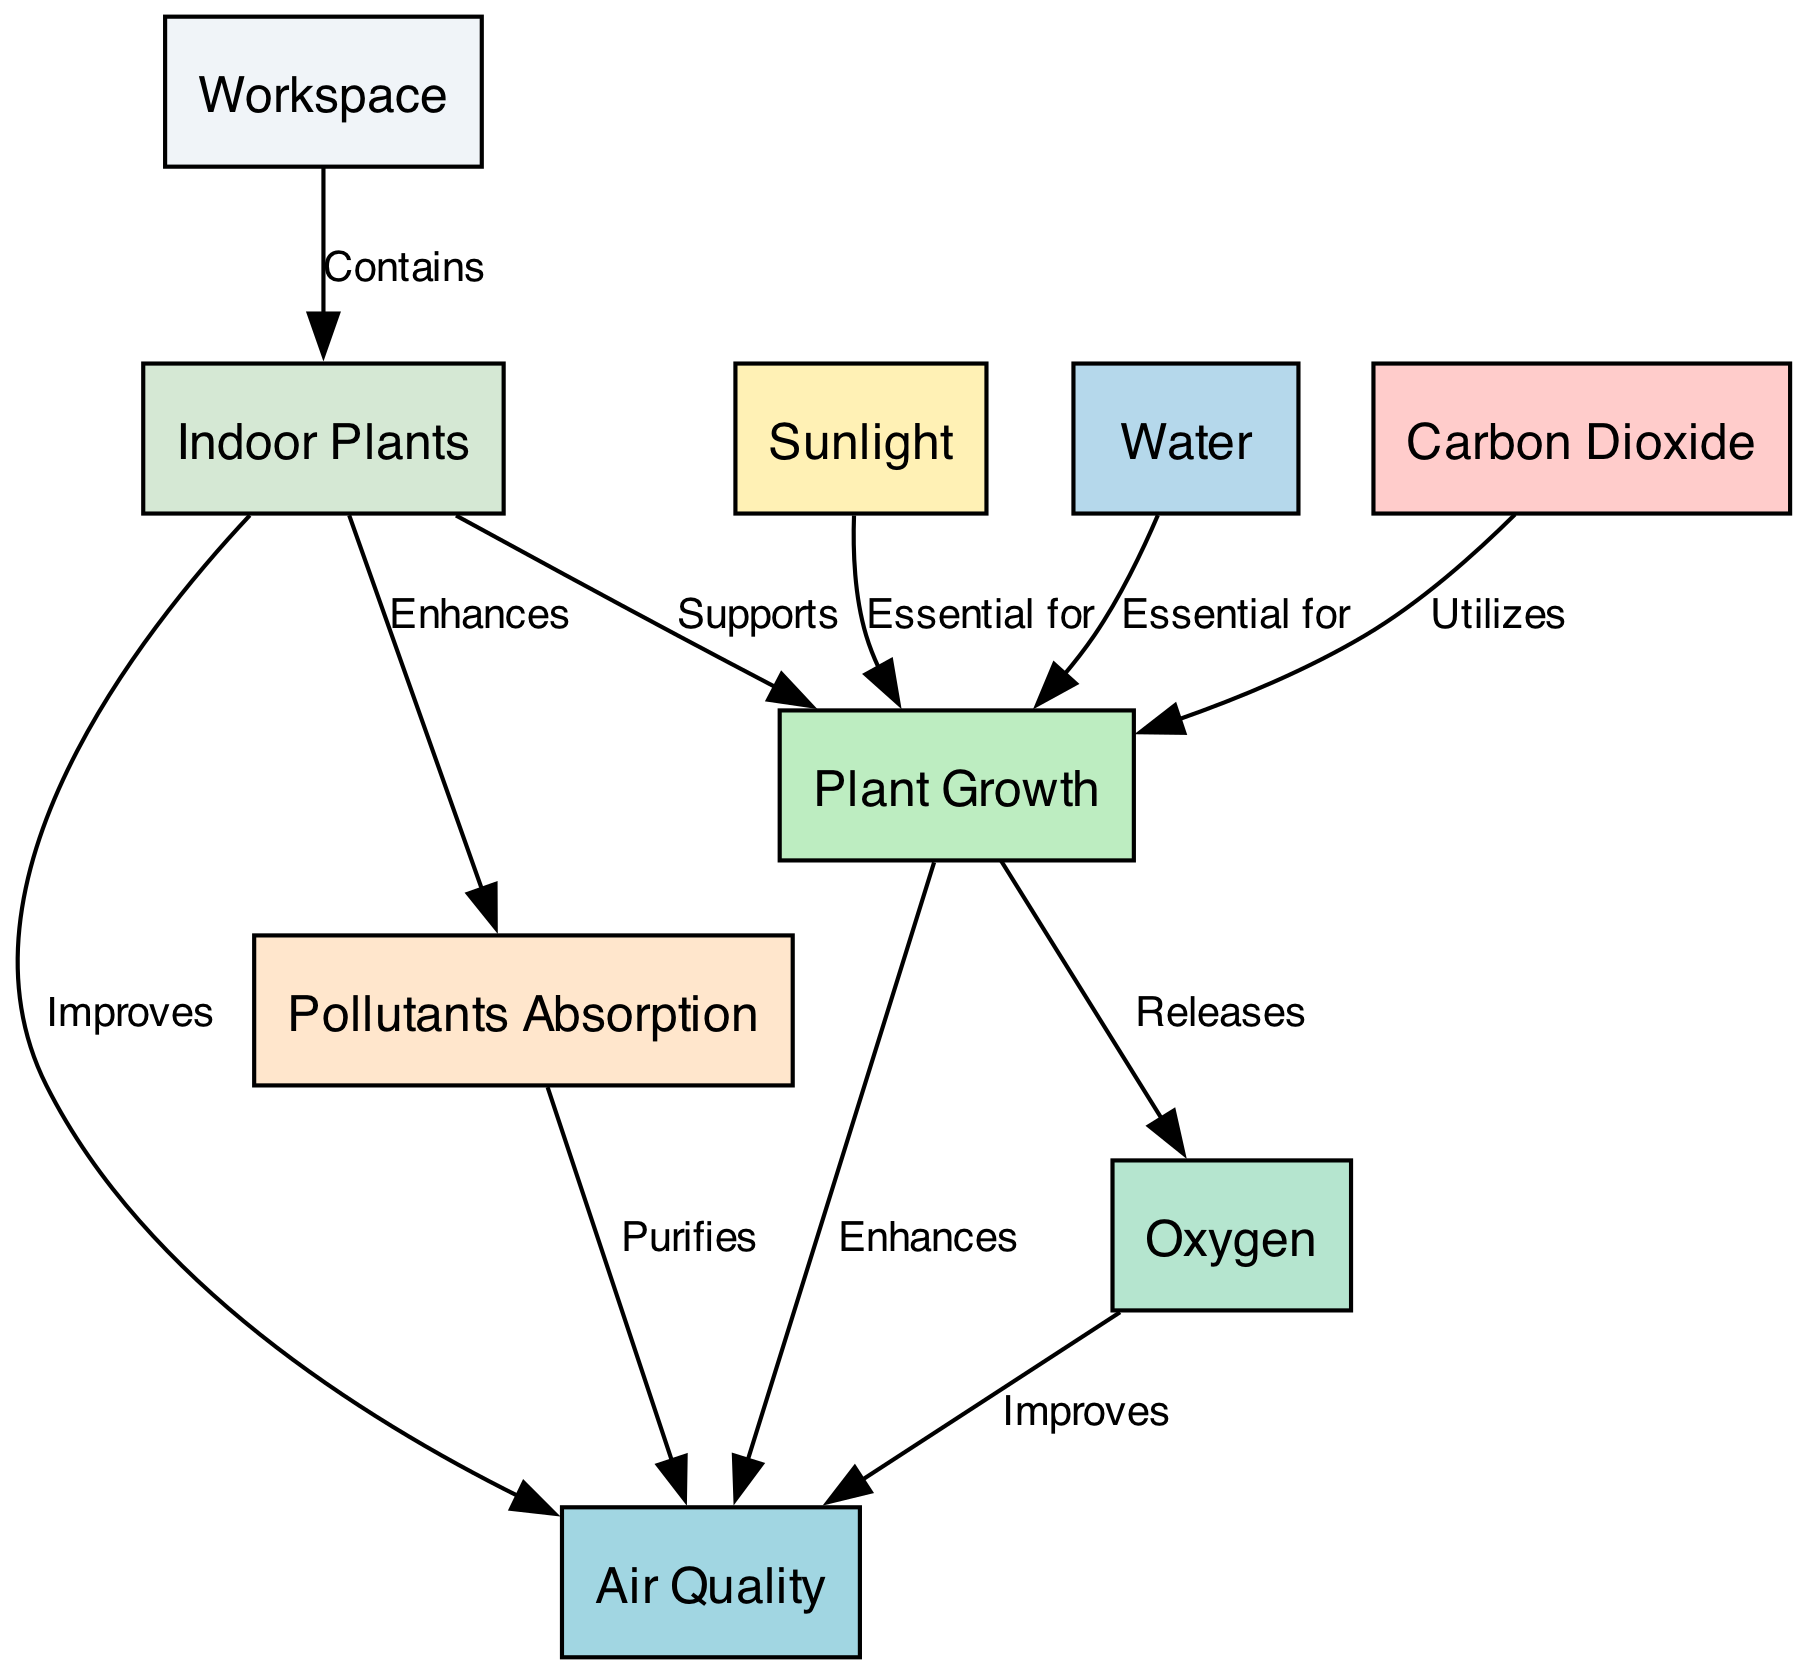What nodes are present in the diagram? The nodes listed in the diagram are: Workspace, Plant Growth, Air Quality, Sunlight, Water, Carbon Dioxide, Oxygen, Indoor Plants, and Pollutants Absorption.
Answer: Workspace, Plant Growth, Air Quality, Sunlight, Water, Carbon Dioxide, Oxygen, Indoor Plants, Pollutants Absorption How many edges are there in the diagram? By counting the relationships listed in the edges section, there are a total of 11 edges connecting the nodes in the diagram.
Answer: 11 What does the "Indoor Plants" node improve? The diagram explicitly states that the "Indoor Plants" node improves the "Air Quality" node, indicating a direct relationship.
Answer: Air Quality What supports "Plant Growth"? The edges indicate that "Indoor Plants" support "Plant Growth," while also influencing growth factors such as "Sunlight" and "Water."
Answer: Indoor Plants What does "Plant Growth" release, and how does it affect air quality? The "Plant Growth" node releases "Oxygen," which improves air quality, according to the connections shown in the diagram.
Answer: Oxygen What essential factors contribute to "Plant Growth"? The diagram indicates that both "Sunlight" and "Water" are essential for "Plant Growth," as they directly provide the necessary resources for plants to thrive.
Answer: Sunlight, Water How does "Pollutants Absorption" relate to "Air Quality"? The diagram shows that "Pollutants Absorption" enhances and purifies air quality, indicating that it plays a crucial role in maintaining a healthy atmosphere within the workspace.
Answer: Purifies What process utilizes "Carbon Dioxide"? The "Plant Growth" node utilizes "Carbon Dioxide," as presented in the edges, indicating its importance in the photosynthesis process essential for plant development.
Answer: Utilizes What node is essential for releasing oxygen and how is it connected to air quality? The "Plant Growth" node is essential for releasing "Oxygen," which then improves the "Air Quality," demonstrating the interconnectedness of these elements within the workspace.
Answer: Plant Growth 